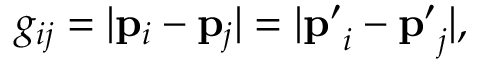Convert formula to latex. <formula><loc_0><loc_0><loc_500><loc_500>g _ { i j } = | p _ { i } - p _ { j } | = | p ^ { \prime } _ { i } - p ^ { \prime } _ { j } | ,</formula> 